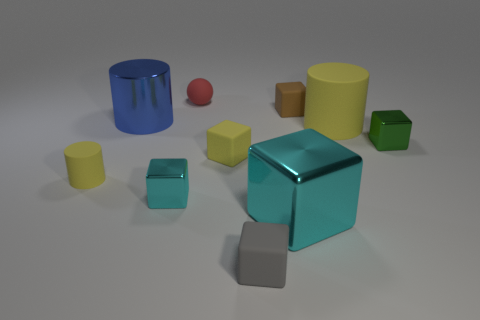Subtract all gray cubes. How many cubes are left? 5 Subtract all tiny gray matte cubes. How many cubes are left? 5 Subtract all cyan cubes. Subtract all blue spheres. How many cubes are left? 4 Subtract all balls. How many objects are left? 9 Subtract 0 cyan balls. How many objects are left? 10 Subtract all green objects. Subtract all large cyan things. How many objects are left? 8 Add 7 small cyan metal objects. How many small cyan metal objects are left? 8 Add 8 green shiny blocks. How many green shiny blocks exist? 9 